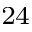<formula> <loc_0><loc_0><loc_500><loc_500>^ { 2 4 }</formula> 